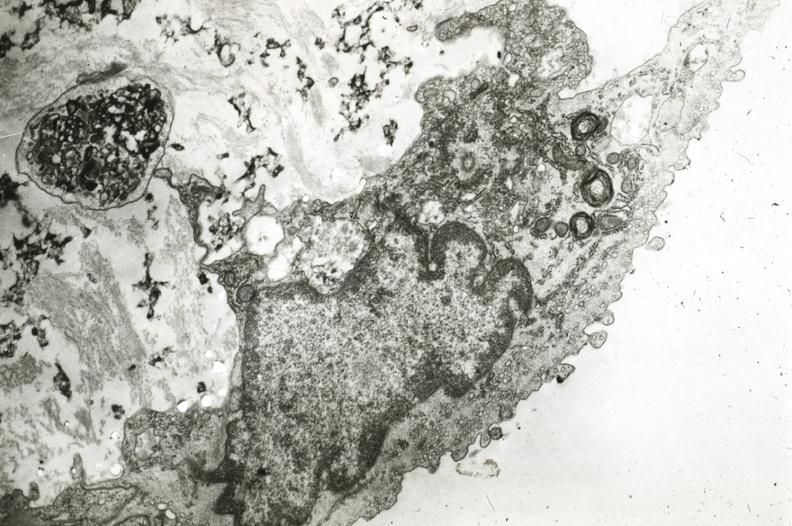s coronary artery present?
Answer the question using a single word or phrase. Yes 